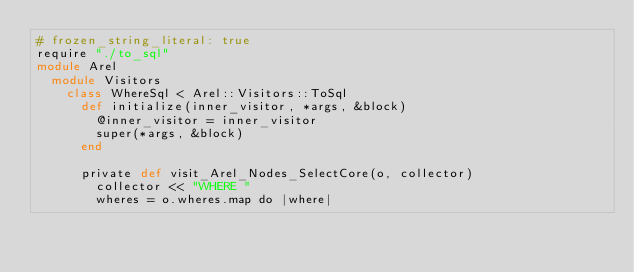Convert code to text. <code><loc_0><loc_0><loc_500><loc_500><_Crystal_># frozen_string_literal: true
require "./to_sql"
module Arel
  module Visitors
    class WhereSql < Arel::Visitors::ToSql
      def initialize(inner_visitor, *args, &block)
        @inner_visitor = inner_visitor
        super(*args, &block)
      end

      private def visit_Arel_Nodes_SelectCore(o, collector)
        collector << "WHERE "
        wheres = o.wheres.map do |where|</code> 